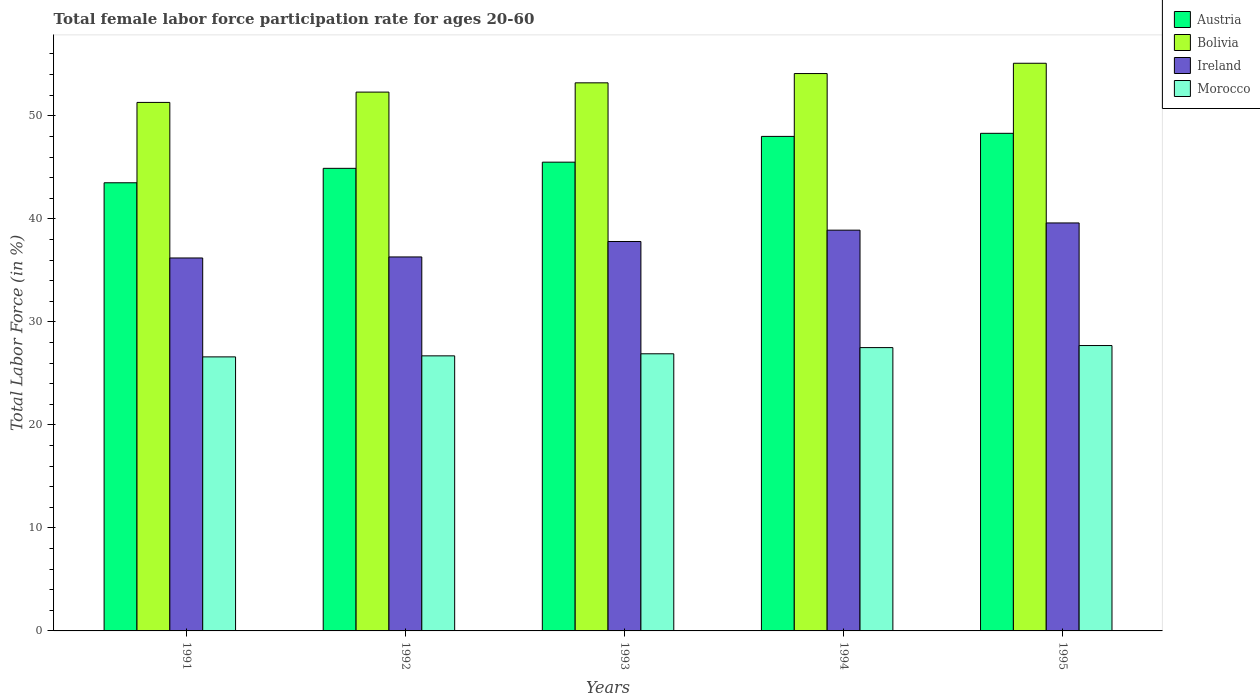Are the number of bars on each tick of the X-axis equal?
Provide a short and direct response. Yes. How many bars are there on the 5th tick from the left?
Keep it short and to the point. 4. How many bars are there on the 2nd tick from the right?
Offer a very short reply. 4. What is the label of the 1st group of bars from the left?
Provide a succinct answer. 1991. What is the female labor force participation rate in Austria in 1991?
Give a very brief answer. 43.5. Across all years, what is the maximum female labor force participation rate in Bolivia?
Keep it short and to the point. 55.1. Across all years, what is the minimum female labor force participation rate in Morocco?
Offer a very short reply. 26.6. In which year was the female labor force participation rate in Morocco minimum?
Offer a terse response. 1991. What is the total female labor force participation rate in Austria in the graph?
Your response must be concise. 230.2. What is the difference between the female labor force participation rate in Morocco in 1994 and that in 1995?
Provide a short and direct response. -0.2. What is the average female labor force participation rate in Bolivia per year?
Keep it short and to the point. 53.2. In the year 1995, what is the difference between the female labor force participation rate in Morocco and female labor force participation rate in Austria?
Your answer should be very brief. -20.6. What is the ratio of the female labor force participation rate in Ireland in 1994 to that in 1995?
Offer a very short reply. 0.98. Is the female labor force participation rate in Bolivia in 1992 less than that in 1995?
Give a very brief answer. Yes. What is the difference between the highest and the second highest female labor force participation rate in Morocco?
Ensure brevity in your answer.  0.2. What is the difference between the highest and the lowest female labor force participation rate in Ireland?
Your answer should be compact. 3.4. In how many years, is the female labor force participation rate in Morocco greater than the average female labor force participation rate in Morocco taken over all years?
Provide a short and direct response. 2. Is it the case that in every year, the sum of the female labor force participation rate in Morocco and female labor force participation rate in Ireland is greater than the sum of female labor force participation rate in Austria and female labor force participation rate in Bolivia?
Offer a terse response. No. What does the 4th bar from the left in 1992 represents?
Offer a very short reply. Morocco. What does the 2nd bar from the right in 1994 represents?
Your answer should be very brief. Ireland. Is it the case that in every year, the sum of the female labor force participation rate in Bolivia and female labor force participation rate in Morocco is greater than the female labor force participation rate in Austria?
Ensure brevity in your answer.  Yes. How many bars are there?
Ensure brevity in your answer.  20. How many years are there in the graph?
Your response must be concise. 5. What is the difference between two consecutive major ticks on the Y-axis?
Provide a short and direct response. 10. Are the values on the major ticks of Y-axis written in scientific E-notation?
Offer a terse response. No. Does the graph contain grids?
Provide a succinct answer. No. How many legend labels are there?
Your response must be concise. 4. What is the title of the graph?
Give a very brief answer. Total female labor force participation rate for ages 20-60. What is the label or title of the X-axis?
Your response must be concise. Years. What is the Total Labor Force (in %) of Austria in 1991?
Give a very brief answer. 43.5. What is the Total Labor Force (in %) of Bolivia in 1991?
Give a very brief answer. 51.3. What is the Total Labor Force (in %) of Ireland in 1991?
Your answer should be compact. 36.2. What is the Total Labor Force (in %) of Morocco in 1991?
Your answer should be compact. 26.6. What is the Total Labor Force (in %) of Austria in 1992?
Your answer should be very brief. 44.9. What is the Total Labor Force (in %) in Bolivia in 1992?
Provide a short and direct response. 52.3. What is the Total Labor Force (in %) of Ireland in 1992?
Offer a terse response. 36.3. What is the Total Labor Force (in %) in Morocco in 1992?
Your answer should be very brief. 26.7. What is the Total Labor Force (in %) in Austria in 1993?
Make the answer very short. 45.5. What is the Total Labor Force (in %) of Bolivia in 1993?
Ensure brevity in your answer.  53.2. What is the Total Labor Force (in %) of Ireland in 1993?
Your answer should be very brief. 37.8. What is the Total Labor Force (in %) of Morocco in 1993?
Keep it short and to the point. 26.9. What is the Total Labor Force (in %) of Bolivia in 1994?
Ensure brevity in your answer.  54.1. What is the Total Labor Force (in %) in Ireland in 1994?
Your answer should be very brief. 38.9. What is the Total Labor Force (in %) of Morocco in 1994?
Provide a short and direct response. 27.5. What is the Total Labor Force (in %) in Austria in 1995?
Provide a succinct answer. 48.3. What is the Total Labor Force (in %) of Bolivia in 1995?
Ensure brevity in your answer.  55.1. What is the Total Labor Force (in %) in Ireland in 1995?
Your answer should be compact. 39.6. What is the Total Labor Force (in %) of Morocco in 1995?
Offer a terse response. 27.7. Across all years, what is the maximum Total Labor Force (in %) in Austria?
Provide a short and direct response. 48.3. Across all years, what is the maximum Total Labor Force (in %) of Bolivia?
Your answer should be compact. 55.1. Across all years, what is the maximum Total Labor Force (in %) in Ireland?
Provide a succinct answer. 39.6. Across all years, what is the maximum Total Labor Force (in %) of Morocco?
Make the answer very short. 27.7. Across all years, what is the minimum Total Labor Force (in %) of Austria?
Offer a very short reply. 43.5. Across all years, what is the minimum Total Labor Force (in %) of Bolivia?
Provide a succinct answer. 51.3. Across all years, what is the minimum Total Labor Force (in %) in Ireland?
Your answer should be very brief. 36.2. Across all years, what is the minimum Total Labor Force (in %) of Morocco?
Keep it short and to the point. 26.6. What is the total Total Labor Force (in %) in Austria in the graph?
Your answer should be compact. 230.2. What is the total Total Labor Force (in %) of Bolivia in the graph?
Give a very brief answer. 266. What is the total Total Labor Force (in %) in Ireland in the graph?
Ensure brevity in your answer.  188.8. What is the total Total Labor Force (in %) in Morocco in the graph?
Your response must be concise. 135.4. What is the difference between the Total Labor Force (in %) in Austria in 1991 and that in 1992?
Ensure brevity in your answer.  -1.4. What is the difference between the Total Labor Force (in %) in Bolivia in 1991 and that in 1992?
Provide a succinct answer. -1. What is the difference between the Total Labor Force (in %) in Morocco in 1991 and that in 1992?
Give a very brief answer. -0.1. What is the difference between the Total Labor Force (in %) in Bolivia in 1991 and that in 1993?
Keep it short and to the point. -1.9. What is the difference between the Total Labor Force (in %) of Ireland in 1991 and that in 1993?
Ensure brevity in your answer.  -1.6. What is the difference between the Total Labor Force (in %) of Morocco in 1991 and that in 1993?
Offer a very short reply. -0.3. What is the difference between the Total Labor Force (in %) in Austria in 1991 and that in 1994?
Offer a very short reply. -4.5. What is the difference between the Total Labor Force (in %) in Bolivia in 1991 and that in 1994?
Keep it short and to the point. -2.8. What is the difference between the Total Labor Force (in %) in Ireland in 1991 and that in 1994?
Make the answer very short. -2.7. What is the difference between the Total Labor Force (in %) in Austria in 1991 and that in 1995?
Keep it short and to the point. -4.8. What is the difference between the Total Labor Force (in %) of Bolivia in 1991 and that in 1995?
Provide a succinct answer. -3.8. What is the difference between the Total Labor Force (in %) in Morocco in 1991 and that in 1995?
Provide a succinct answer. -1.1. What is the difference between the Total Labor Force (in %) of Ireland in 1992 and that in 1993?
Give a very brief answer. -1.5. What is the difference between the Total Labor Force (in %) of Bolivia in 1992 and that in 1994?
Your answer should be compact. -1.8. What is the difference between the Total Labor Force (in %) in Ireland in 1992 and that in 1994?
Your answer should be very brief. -2.6. What is the difference between the Total Labor Force (in %) in Morocco in 1992 and that in 1994?
Make the answer very short. -0.8. What is the difference between the Total Labor Force (in %) in Ireland in 1992 and that in 1995?
Provide a succinct answer. -3.3. What is the difference between the Total Labor Force (in %) of Morocco in 1992 and that in 1995?
Offer a very short reply. -1. What is the difference between the Total Labor Force (in %) of Ireland in 1993 and that in 1994?
Offer a very short reply. -1.1. What is the difference between the Total Labor Force (in %) of Bolivia in 1993 and that in 1995?
Provide a succinct answer. -1.9. What is the difference between the Total Labor Force (in %) of Austria in 1994 and that in 1995?
Provide a succinct answer. -0.3. What is the difference between the Total Labor Force (in %) in Ireland in 1994 and that in 1995?
Provide a succinct answer. -0.7. What is the difference between the Total Labor Force (in %) in Morocco in 1994 and that in 1995?
Ensure brevity in your answer.  -0.2. What is the difference between the Total Labor Force (in %) of Austria in 1991 and the Total Labor Force (in %) of Bolivia in 1992?
Offer a terse response. -8.8. What is the difference between the Total Labor Force (in %) of Austria in 1991 and the Total Labor Force (in %) of Ireland in 1992?
Provide a short and direct response. 7.2. What is the difference between the Total Labor Force (in %) of Austria in 1991 and the Total Labor Force (in %) of Morocco in 1992?
Provide a succinct answer. 16.8. What is the difference between the Total Labor Force (in %) in Bolivia in 1991 and the Total Labor Force (in %) in Ireland in 1992?
Offer a very short reply. 15. What is the difference between the Total Labor Force (in %) in Bolivia in 1991 and the Total Labor Force (in %) in Morocco in 1992?
Offer a terse response. 24.6. What is the difference between the Total Labor Force (in %) in Austria in 1991 and the Total Labor Force (in %) in Bolivia in 1993?
Provide a short and direct response. -9.7. What is the difference between the Total Labor Force (in %) in Austria in 1991 and the Total Labor Force (in %) in Ireland in 1993?
Offer a very short reply. 5.7. What is the difference between the Total Labor Force (in %) in Austria in 1991 and the Total Labor Force (in %) in Morocco in 1993?
Provide a succinct answer. 16.6. What is the difference between the Total Labor Force (in %) of Bolivia in 1991 and the Total Labor Force (in %) of Morocco in 1993?
Your response must be concise. 24.4. What is the difference between the Total Labor Force (in %) of Bolivia in 1991 and the Total Labor Force (in %) of Morocco in 1994?
Provide a succinct answer. 23.8. What is the difference between the Total Labor Force (in %) of Austria in 1991 and the Total Labor Force (in %) of Ireland in 1995?
Ensure brevity in your answer.  3.9. What is the difference between the Total Labor Force (in %) of Austria in 1991 and the Total Labor Force (in %) of Morocco in 1995?
Your response must be concise. 15.8. What is the difference between the Total Labor Force (in %) of Bolivia in 1991 and the Total Labor Force (in %) of Ireland in 1995?
Your response must be concise. 11.7. What is the difference between the Total Labor Force (in %) in Bolivia in 1991 and the Total Labor Force (in %) in Morocco in 1995?
Provide a short and direct response. 23.6. What is the difference between the Total Labor Force (in %) in Austria in 1992 and the Total Labor Force (in %) in Bolivia in 1993?
Provide a succinct answer. -8.3. What is the difference between the Total Labor Force (in %) of Austria in 1992 and the Total Labor Force (in %) of Ireland in 1993?
Your answer should be compact. 7.1. What is the difference between the Total Labor Force (in %) of Bolivia in 1992 and the Total Labor Force (in %) of Ireland in 1993?
Your answer should be compact. 14.5. What is the difference between the Total Labor Force (in %) of Bolivia in 1992 and the Total Labor Force (in %) of Morocco in 1993?
Offer a very short reply. 25.4. What is the difference between the Total Labor Force (in %) of Austria in 1992 and the Total Labor Force (in %) of Bolivia in 1994?
Your answer should be compact. -9.2. What is the difference between the Total Labor Force (in %) of Bolivia in 1992 and the Total Labor Force (in %) of Morocco in 1994?
Give a very brief answer. 24.8. What is the difference between the Total Labor Force (in %) in Ireland in 1992 and the Total Labor Force (in %) in Morocco in 1994?
Keep it short and to the point. 8.8. What is the difference between the Total Labor Force (in %) of Austria in 1992 and the Total Labor Force (in %) of Morocco in 1995?
Your answer should be very brief. 17.2. What is the difference between the Total Labor Force (in %) of Bolivia in 1992 and the Total Labor Force (in %) of Ireland in 1995?
Offer a terse response. 12.7. What is the difference between the Total Labor Force (in %) in Bolivia in 1992 and the Total Labor Force (in %) in Morocco in 1995?
Keep it short and to the point. 24.6. What is the difference between the Total Labor Force (in %) of Austria in 1993 and the Total Labor Force (in %) of Ireland in 1994?
Ensure brevity in your answer.  6.6. What is the difference between the Total Labor Force (in %) in Austria in 1993 and the Total Labor Force (in %) in Morocco in 1994?
Keep it short and to the point. 18. What is the difference between the Total Labor Force (in %) in Bolivia in 1993 and the Total Labor Force (in %) in Ireland in 1994?
Offer a very short reply. 14.3. What is the difference between the Total Labor Force (in %) in Bolivia in 1993 and the Total Labor Force (in %) in Morocco in 1994?
Make the answer very short. 25.7. What is the difference between the Total Labor Force (in %) in Ireland in 1993 and the Total Labor Force (in %) in Morocco in 1994?
Give a very brief answer. 10.3. What is the difference between the Total Labor Force (in %) in Ireland in 1993 and the Total Labor Force (in %) in Morocco in 1995?
Give a very brief answer. 10.1. What is the difference between the Total Labor Force (in %) in Austria in 1994 and the Total Labor Force (in %) in Morocco in 1995?
Provide a short and direct response. 20.3. What is the difference between the Total Labor Force (in %) of Bolivia in 1994 and the Total Labor Force (in %) of Ireland in 1995?
Your answer should be compact. 14.5. What is the difference between the Total Labor Force (in %) of Bolivia in 1994 and the Total Labor Force (in %) of Morocco in 1995?
Your response must be concise. 26.4. What is the difference between the Total Labor Force (in %) of Ireland in 1994 and the Total Labor Force (in %) of Morocco in 1995?
Your answer should be very brief. 11.2. What is the average Total Labor Force (in %) in Austria per year?
Ensure brevity in your answer.  46.04. What is the average Total Labor Force (in %) in Bolivia per year?
Make the answer very short. 53.2. What is the average Total Labor Force (in %) in Ireland per year?
Give a very brief answer. 37.76. What is the average Total Labor Force (in %) in Morocco per year?
Offer a terse response. 27.08. In the year 1991, what is the difference between the Total Labor Force (in %) of Austria and Total Labor Force (in %) of Ireland?
Provide a succinct answer. 7.3. In the year 1991, what is the difference between the Total Labor Force (in %) of Austria and Total Labor Force (in %) of Morocco?
Offer a very short reply. 16.9. In the year 1991, what is the difference between the Total Labor Force (in %) in Bolivia and Total Labor Force (in %) in Ireland?
Give a very brief answer. 15.1. In the year 1991, what is the difference between the Total Labor Force (in %) of Bolivia and Total Labor Force (in %) of Morocco?
Your response must be concise. 24.7. In the year 1992, what is the difference between the Total Labor Force (in %) in Austria and Total Labor Force (in %) in Bolivia?
Offer a very short reply. -7.4. In the year 1992, what is the difference between the Total Labor Force (in %) of Bolivia and Total Labor Force (in %) of Morocco?
Provide a short and direct response. 25.6. In the year 1992, what is the difference between the Total Labor Force (in %) of Ireland and Total Labor Force (in %) of Morocco?
Offer a very short reply. 9.6. In the year 1993, what is the difference between the Total Labor Force (in %) of Bolivia and Total Labor Force (in %) of Morocco?
Offer a terse response. 26.3. In the year 1993, what is the difference between the Total Labor Force (in %) in Ireland and Total Labor Force (in %) in Morocco?
Give a very brief answer. 10.9. In the year 1994, what is the difference between the Total Labor Force (in %) in Austria and Total Labor Force (in %) in Morocco?
Your answer should be very brief. 20.5. In the year 1994, what is the difference between the Total Labor Force (in %) of Bolivia and Total Labor Force (in %) of Ireland?
Provide a short and direct response. 15.2. In the year 1994, what is the difference between the Total Labor Force (in %) of Bolivia and Total Labor Force (in %) of Morocco?
Offer a terse response. 26.6. In the year 1994, what is the difference between the Total Labor Force (in %) of Ireland and Total Labor Force (in %) of Morocco?
Your answer should be very brief. 11.4. In the year 1995, what is the difference between the Total Labor Force (in %) in Austria and Total Labor Force (in %) in Morocco?
Your answer should be very brief. 20.6. In the year 1995, what is the difference between the Total Labor Force (in %) of Bolivia and Total Labor Force (in %) of Morocco?
Your answer should be compact. 27.4. What is the ratio of the Total Labor Force (in %) of Austria in 1991 to that in 1992?
Your answer should be compact. 0.97. What is the ratio of the Total Labor Force (in %) in Bolivia in 1991 to that in 1992?
Provide a short and direct response. 0.98. What is the ratio of the Total Labor Force (in %) in Morocco in 1991 to that in 1992?
Your answer should be very brief. 1. What is the ratio of the Total Labor Force (in %) in Austria in 1991 to that in 1993?
Your answer should be very brief. 0.96. What is the ratio of the Total Labor Force (in %) in Bolivia in 1991 to that in 1993?
Your answer should be very brief. 0.96. What is the ratio of the Total Labor Force (in %) in Ireland in 1991 to that in 1993?
Ensure brevity in your answer.  0.96. What is the ratio of the Total Labor Force (in %) in Morocco in 1991 to that in 1993?
Provide a succinct answer. 0.99. What is the ratio of the Total Labor Force (in %) in Austria in 1991 to that in 1994?
Your answer should be very brief. 0.91. What is the ratio of the Total Labor Force (in %) in Bolivia in 1991 to that in 1994?
Give a very brief answer. 0.95. What is the ratio of the Total Labor Force (in %) in Ireland in 1991 to that in 1994?
Give a very brief answer. 0.93. What is the ratio of the Total Labor Force (in %) in Morocco in 1991 to that in 1994?
Give a very brief answer. 0.97. What is the ratio of the Total Labor Force (in %) of Austria in 1991 to that in 1995?
Make the answer very short. 0.9. What is the ratio of the Total Labor Force (in %) of Bolivia in 1991 to that in 1995?
Provide a succinct answer. 0.93. What is the ratio of the Total Labor Force (in %) in Ireland in 1991 to that in 1995?
Your response must be concise. 0.91. What is the ratio of the Total Labor Force (in %) in Morocco in 1991 to that in 1995?
Your answer should be compact. 0.96. What is the ratio of the Total Labor Force (in %) of Bolivia in 1992 to that in 1993?
Ensure brevity in your answer.  0.98. What is the ratio of the Total Labor Force (in %) of Ireland in 1992 to that in 1993?
Ensure brevity in your answer.  0.96. What is the ratio of the Total Labor Force (in %) of Morocco in 1992 to that in 1993?
Give a very brief answer. 0.99. What is the ratio of the Total Labor Force (in %) in Austria in 1992 to that in 1994?
Your answer should be compact. 0.94. What is the ratio of the Total Labor Force (in %) in Bolivia in 1992 to that in 1994?
Give a very brief answer. 0.97. What is the ratio of the Total Labor Force (in %) of Ireland in 1992 to that in 1994?
Offer a terse response. 0.93. What is the ratio of the Total Labor Force (in %) in Morocco in 1992 to that in 1994?
Your answer should be very brief. 0.97. What is the ratio of the Total Labor Force (in %) in Austria in 1992 to that in 1995?
Offer a very short reply. 0.93. What is the ratio of the Total Labor Force (in %) in Bolivia in 1992 to that in 1995?
Offer a very short reply. 0.95. What is the ratio of the Total Labor Force (in %) of Ireland in 1992 to that in 1995?
Provide a short and direct response. 0.92. What is the ratio of the Total Labor Force (in %) in Morocco in 1992 to that in 1995?
Keep it short and to the point. 0.96. What is the ratio of the Total Labor Force (in %) in Austria in 1993 to that in 1994?
Keep it short and to the point. 0.95. What is the ratio of the Total Labor Force (in %) in Bolivia in 1993 to that in 1994?
Your response must be concise. 0.98. What is the ratio of the Total Labor Force (in %) in Ireland in 1993 to that in 1994?
Your answer should be very brief. 0.97. What is the ratio of the Total Labor Force (in %) in Morocco in 1993 to that in 1994?
Ensure brevity in your answer.  0.98. What is the ratio of the Total Labor Force (in %) of Austria in 1993 to that in 1995?
Offer a very short reply. 0.94. What is the ratio of the Total Labor Force (in %) of Bolivia in 1993 to that in 1995?
Keep it short and to the point. 0.97. What is the ratio of the Total Labor Force (in %) of Ireland in 1993 to that in 1995?
Provide a succinct answer. 0.95. What is the ratio of the Total Labor Force (in %) of Morocco in 1993 to that in 1995?
Your answer should be compact. 0.97. What is the ratio of the Total Labor Force (in %) of Austria in 1994 to that in 1995?
Offer a terse response. 0.99. What is the ratio of the Total Labor Force (in %) in Bolivia in 1994 to that in 1995?
Keep it short and to the point. 0.98. What is the ratio of the Total Labor Force (in %) of Ireland in 1994 to that in 1995?
Make the answer very short. 0.98. What is the ratio of the Total Labor Force (in %) in Morocco in 1994 to that in 1995?
Your answer should be compact. 0.99. What is the difference between the highest and the second highest Total Labor Force (in %) in Ireland?
Give a very brief answer. 0.7. What is the difference between the highest and the lowest Total Labor Force (in %) of Bolivia?
Give a very brief answer. 3.8. What is the difference between the highest and the lowest Total Labor Force (in %) of Morocco?
Provide a short and direct response. 1.1. 